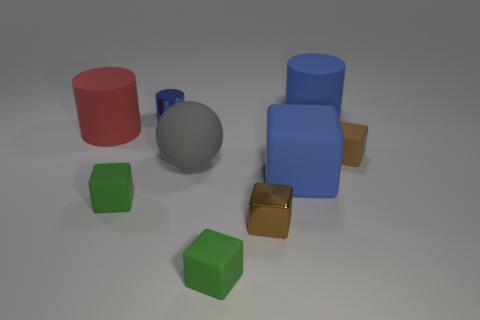Can you describe how each geometric shape in the image could serve a different educational purpose for children? Certainly! The variety of shapes like cylinders, cubes, and spheres can help children learn about geometry and spatial relationships. For example, the sphere can explore concepts of roundness and rolling motion, while cubes can demonstrate stability and stacking principles. Interesting! Could the different colors of the shapes be used to teach any specific concepts? Yes, the diverse colors of the shapes can be used to teach color recognition and sorting. Children could be tasked with grouping the shapes by color or creating patterns, enhancing their cognitive abilities in distinguishing and categorizing. 